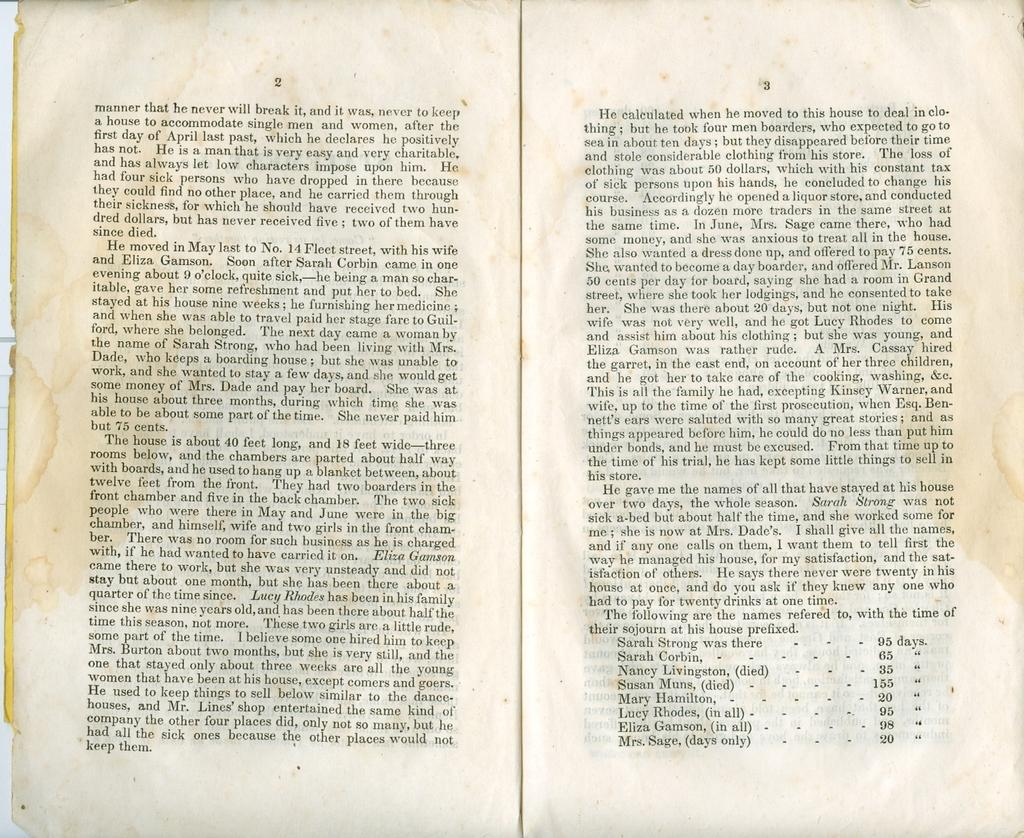<image>
Describe the image concisely. A book is opened to pages 2 and 3 and has a list of ladies names such as Sarah Strong and Sarah Corbin. 